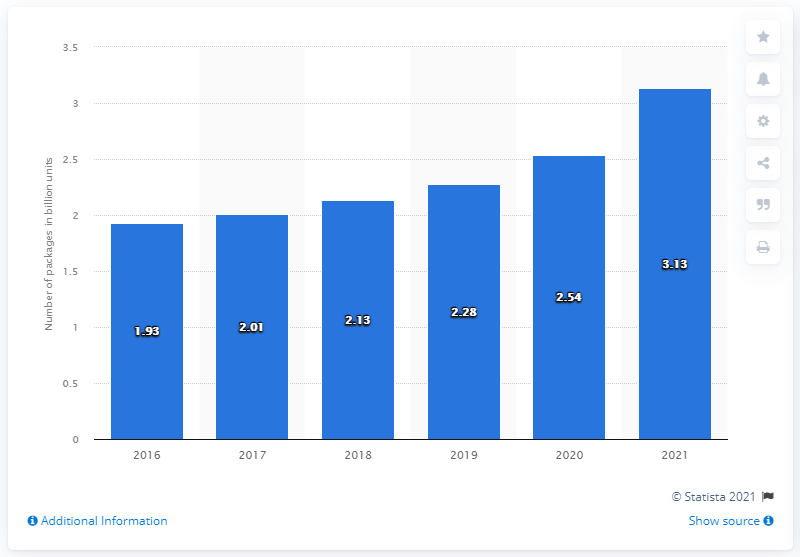Give some essential details in this illustration. The total package volume of FedEx Ground is expected to end in 2021. In the fiscal year of 2016, FedEx Ground was. 